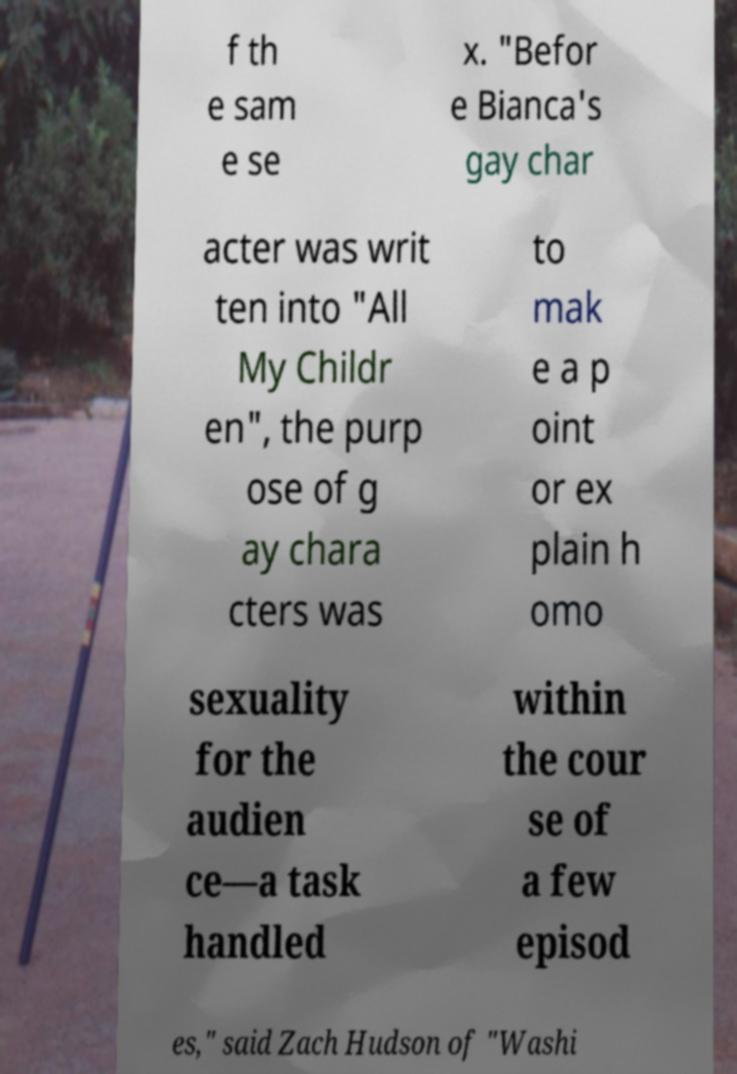Please identify and transcribe the text found in this image. f th e sam e se x. "Befor e Bianca's gay char acter was writ ten into "All My Childr en", the purp ose of g ay chara cters was to mak e a p oint or ex plain h omo sexuality for the audien ce—a task handled within the cour se of a few episod es," said Zach Hudson of "Washi 